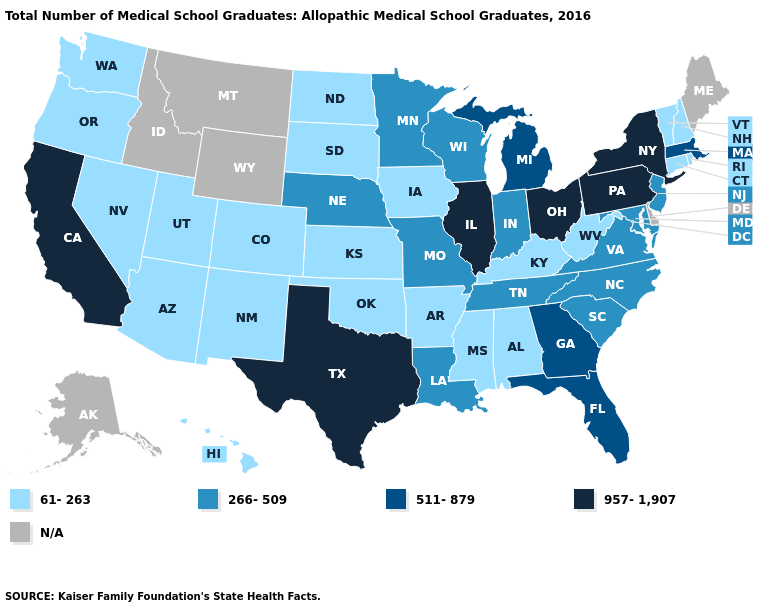Among the states that border Maryland , which have the highest value?
Be succinct. Pennsylvania. Among the states that border Illinois , does Missouri have the highest value?
Quick response, please. Yes. Which states have the lowest value in the USA?
Quick response, please. Alabama, Arizona, Arkansas, Colorado, Connecticut, Hawaii, Iowa, Kansas, Kentucky, Mississippi, Nevada, New Hampshire, New Mexico, North Dakota, Oklahoma, Oregon, Rhode Island, South Dakota, Utah, Vermont, Washington, West Virginia. Which states hav the highest value in the MidWest?
Keep it brief. Illinois, Ohio. Does Rhode Island have the lowest value in the Northeast?
Concise answer only. Yes. Name the states that have a value in the range 511-879?
Write a very short answer. Florida, Georgia, Massachusetts, Michigan. Which states have the lowest value in the Northeast?
Concise answer only. Connecticut, New Hampshire, Rhode Island, Vermont. Name the states that have a value in the range 511-879?
Keep it brief. Florida, Georgia, Massachusetts, Michigan. Does the first symbol in the legend represent the smallest category?
Give a very brief answer. Yes. Does Kentucky have the lowest value in the South?
Be succinct. Yes. Which states have the lowest value in the West?
Be succinct. Arizona, Colorado, Hawaii, Nevada, New Mexico, Oregon, Utah, Washington. What is the highest value in the USA?
Give a very brief answer. 957-1,907. What is the value of Vermont?
Answer briefly. 61-263. Does West Virginia have the lowest value in the South?
Be succinct. Yes. 